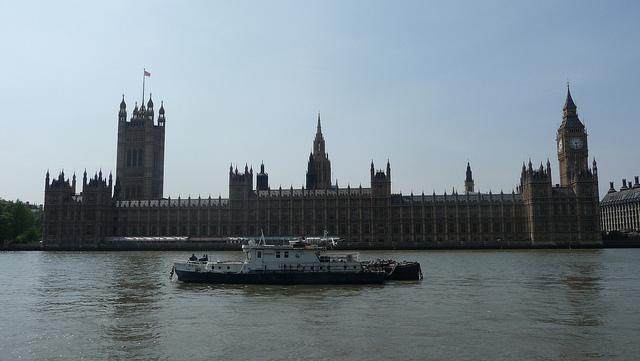How many buildings are in the background?
Concise answer only. 2. How many boats are visible?
Write a very short answer. 1. Who took this picture?
Short answer required. Photographer. Are there waves on the water?
Write a very short answer. No. What river is this?
Give a very brief answer. Thames. Is it a cloudy day?
Give a very brief answer. No. What city was this photo taken in?
Concise answer only. London. 